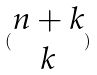Convert formula to latex. <formula><loc_0><loc_0><loc_500><loc_500>( \begin{matrix} n + k \\ k \end{matrix} )</formula> 